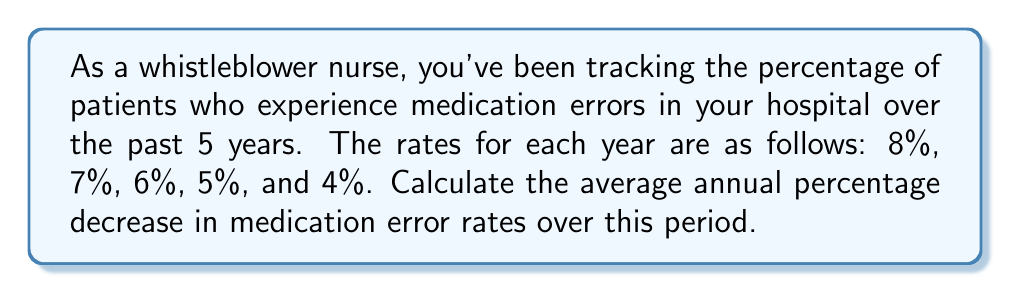Can you answer this question? To solve this problem, we need to follow these steps:

1) First, let's calculate the total percentage decrease over the 5-year period:
   
   Total decrease = Initial rate - Final rate
                  = 8% - 4% = 4%

2) Now, we need to find the average annual decrease. Since we have 5 years of data, we have 4 intervals between these years.

3) To find the average annual decrease, we can use the formula for average rate of change:

   $$ \text{Average annual decrease} = \frac{\text{Total decrease}}{\text{Number of intervals}} $$

4) Substituting our values:

   $$ \text{Average annual decrease} = \frac{4\%}{4} = 1\% $$

5) However, this is not the percentage decrease we're looking for. We need to express this as a percentage of the previous year's rate.

6) To do this, we can use the concept of geometric mean. If we start with 8% and decrease by a constant percentage each year to reach 4% after 4 years, we can use the formula:

   $$ (1-r)^4 = \frac{4\%}{8\%} = 0.5 $$

   Where $r$ is the annual percentage decrease we're looking for.

7) Solving this equation:

   $$ (1-r)^4 = 0.5 $$
   $$ 1-r = 0.5^{\frac{1}{4}} \approx 0.8409 $$
   $$ r \approx 1 - 0.8409 = 0.1591 $$

8) Therefore, the average annual percentage decrease is approximately 15.91%.
Answer: The average annual percentage decrease in medication error rates over the 5-year period is approximately 15.91%. 